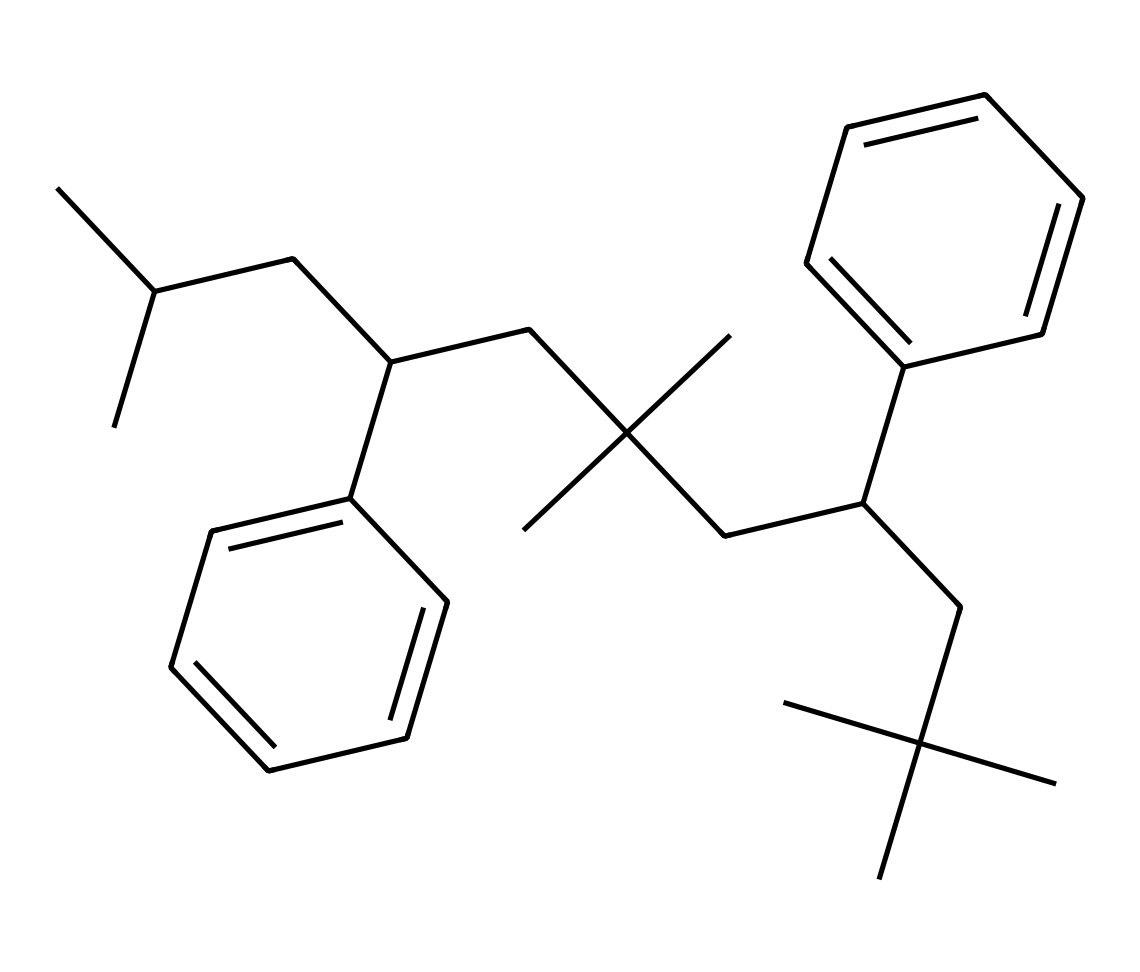What is the molecular formula of this compound? To determine the molecular formula, we need to count the number of carbon (C) and hydrogen (H) atoms in the structure. From analyzing the SMILES, we can see the compound contains 26 carbon atoms and 38 hydrogen atoms.
Answer: C26H38 How many aromatic rings are present in the structure? The structure shows two distinct benzene rings connected by the aliphatic chain, which are typical in polystyrene derivatives. Each benzene ring has alternating double bonds, making them aromatic. Thus, there are two aromatic rings.
Answer: 2 What property is typically imparted to this polymer structure due to the presence of phenyl groups? The phenyl groups in the structure increase the stability and rigidity of the polymer, which is crucial for applications like disposable food containers, ensuring they can withstand heat and pressure.
Answer: stability How does the branched structure affect the melting temperature of this polymer? In polymers like this one with branched structures, the branched chains disrupt the orderly packing of polymer chains, leading to lower crystallinity. This generally results in a lower melting temperature compared to linear polymers.
Answer: lower What is the main type of interaction driving the stability of this polymer? The stability of polystyrene is mainly due to van der Waals forces and induced dipole interactions between the phenyl rings and the aliphatic segments, which contribute to the overall strength of the polymer.
Answer: van der Waals forces What might be a consideration when recycling this type of polymer? The presence of additives or stabilizers during the production of polystyrene can make recycling complicated, as they may not be compatible with all recycling streams, leading to the need for specialized recycling processes.
Answer: additives 